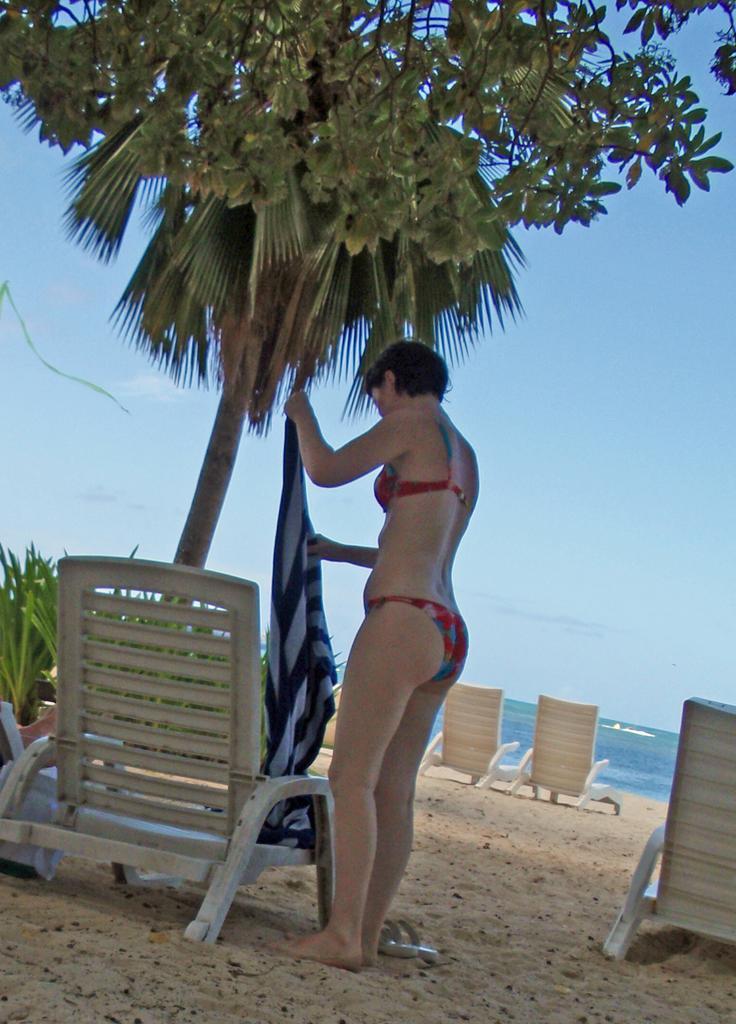Describe this image in one or two sentences. In this picture there is a woman wearing a bikini is standing on the sand and holding a towel in her hands there is a chair in front of her and there is a tree,few chairs and water in the background. 